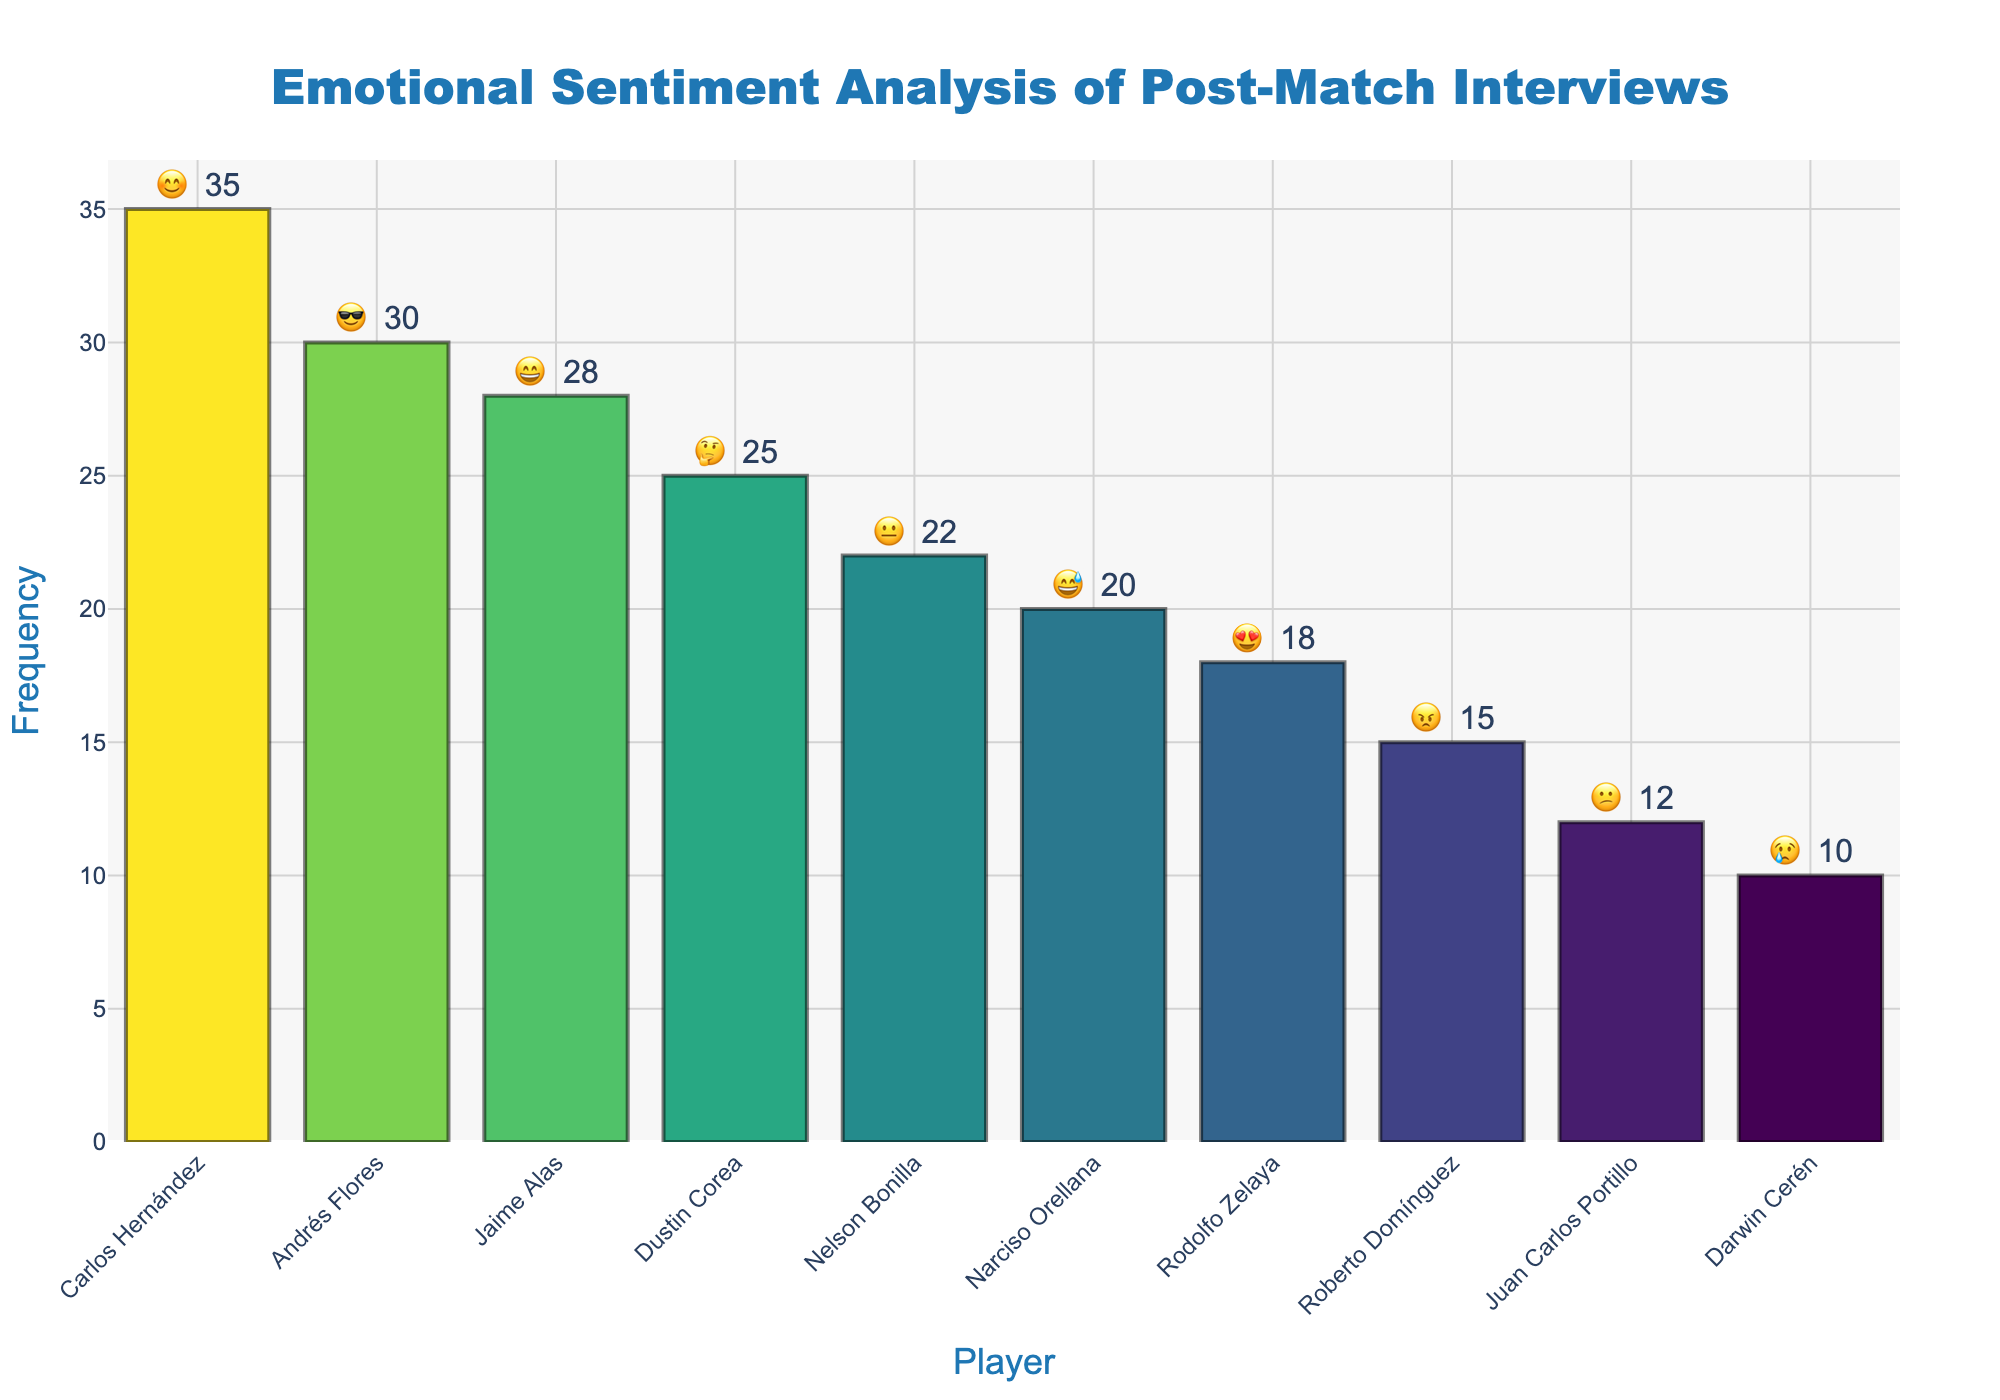What is the title of the chart? The title of the chart is usually displayed at the top and summarizes the main theme of the figure. Here, it is clearly written and helps understand the focus of the chart.
Answer: Emotional Sentiment Analysis of Post-Match Interviews Which player shows the highest frequency of recorded emotions? By looking at the height of the bars and the numbers displayed on top, we can identify the player with the highest value.
Answer: Carlos Hernández How many emotions does Jaime Alas display? The number of emotions for each player is given next to their emoji on top of each bar. Check for the bar labeled with Jaime Alas.
Answer: 28 What is the difference in the frequency of emotions between Carlos Hernández and Darwin Cerén? To find the difference, subtract the frequency of Darwin Cerén from that of Carlos Hernández (35 - 10).
Answer: 25 Who appears more frequently in interviews: Narciso Orellana or Dustin Corea? Compare the height and the frequency number of the bars labeled with Narciso Orellana and Dustin Corea.
Answer: Dustin Corea What is the total frequency of happy (😊) and delighted (😄) emotions? Add up the frequencies of Carlos Hernández (35) and Jaime Alas (28) who represent these emotions respectively (35 + 28).
Answer: 63 Which player is linked with the 'love' (😍) emoji? The emoji next to each player's name can be visually checked to identify the 'love' emoji. Look for the player associated with this emoji.
Answer: Rodolfo Zelaya Which two players have the closest frequency values, and what is the difference? Look at the numbers above the bars and find the closest pair. Dustin Corea (25) and Narciso Orellana (20) are closest. The difference is calculated as 25 - 20.
Answer: 5 How many players have a frequency above 20? Count the number of bars where the frequency is greater than 20.
Answer: 5 What is the most common negative emotion and its frequency? Look for the negative emotions and compare their frequencies (😠, 😢, 😕). 😠 has the highest frequency.
Answer: 😠, 15 